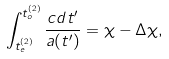Convert formula to latex. <formula><loc_0><loc_0><loc_500><loc_500>\int _ { t _ { e } ^ { ( 2 ) } } ^ { t _ { o } ^ { ( 2 ) } } \frac { c d t ^ { \prime } } { a ( t ^ { \prime } ) } = \chi - \Delta \chi ,</formula> 